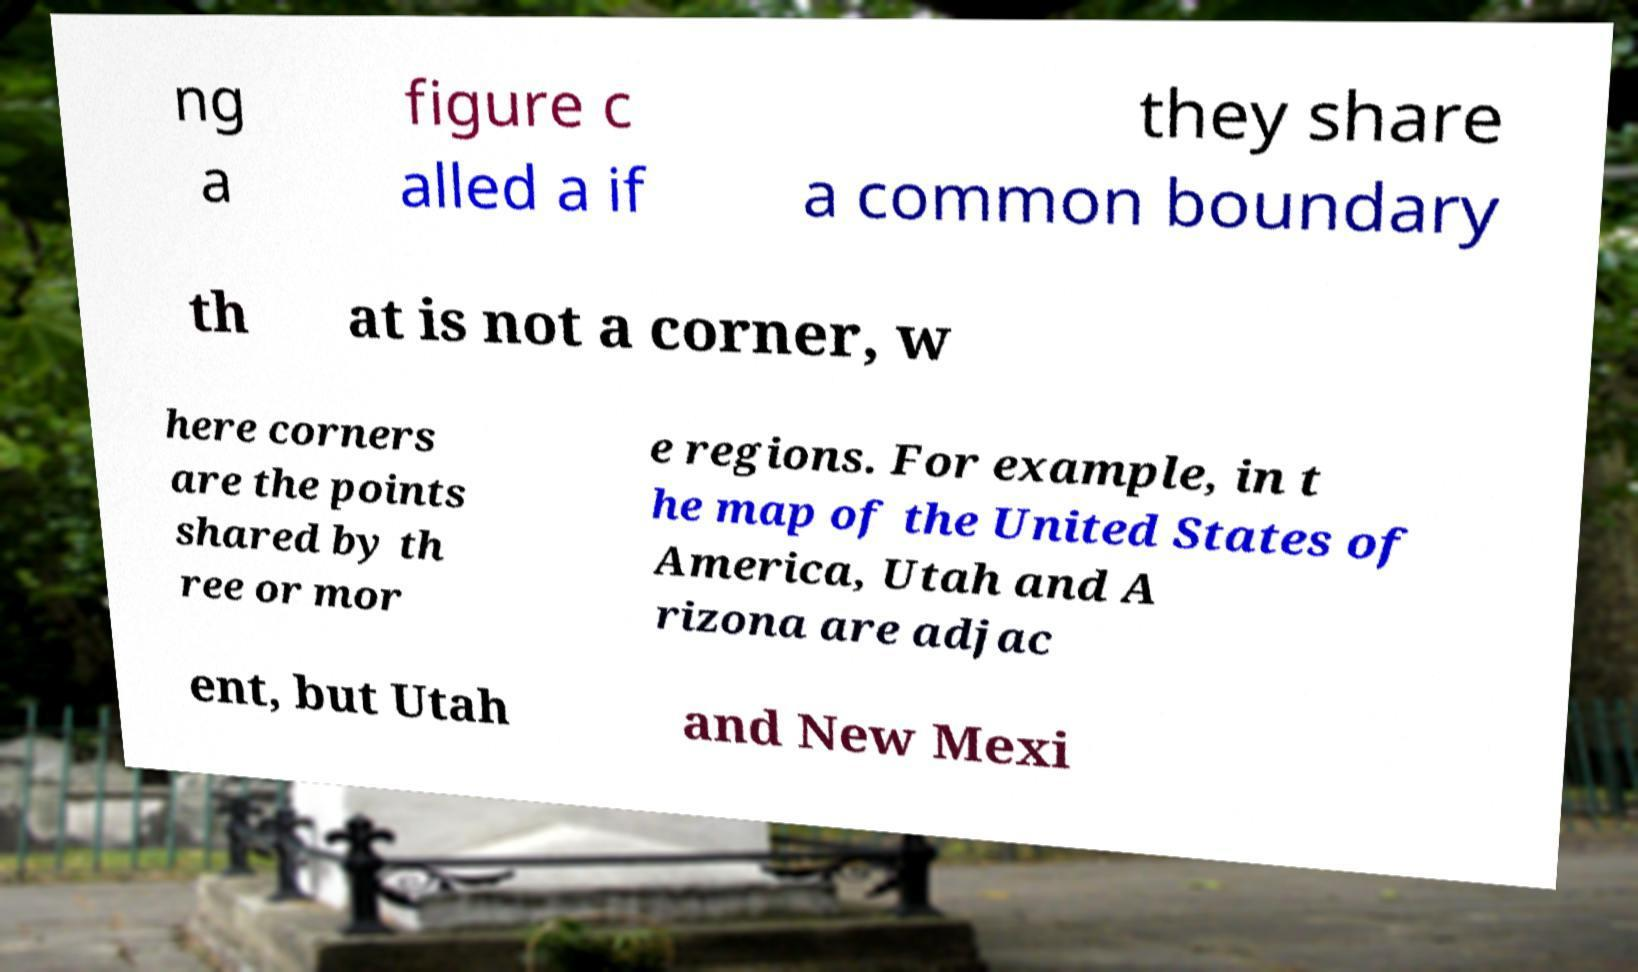Could you extract and type out the text from this image? ng a figure c alled a if they share a common boundary th at is not a corner, w here corners are the points shared by th ree or mor e regions. For example, in t he map of the United States of America, Utah and A rizona are adjac ent, but Utah and New Mexi 